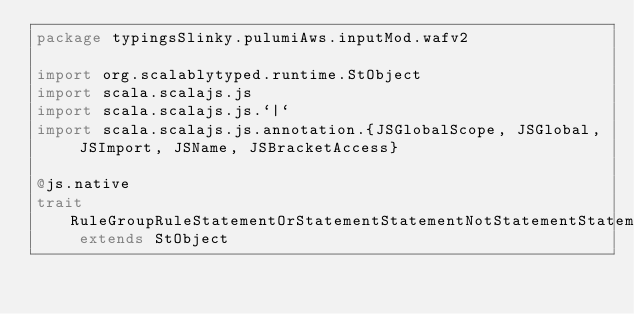Convert code to text. <code><loc_0><loc_0><loc_500><loc_500><_Scala_>package typingsSlinky.pulumiAws.inputMod.wafv2

import org.scalablytyped.runtime.StObject
import scala.scalajs.js
import scala.scalajs.js.`|`
import scala.scalajs.js.annotation.{JSGlobalScope, JSGlobal, JSImport, JSName, JSBracketAccess}

@js.native
trait RuleGroupRuleStatementOrStatementStatementNotStatementStatementByteMatchStatementFieldToMatchMethod extends StObject
</code> 